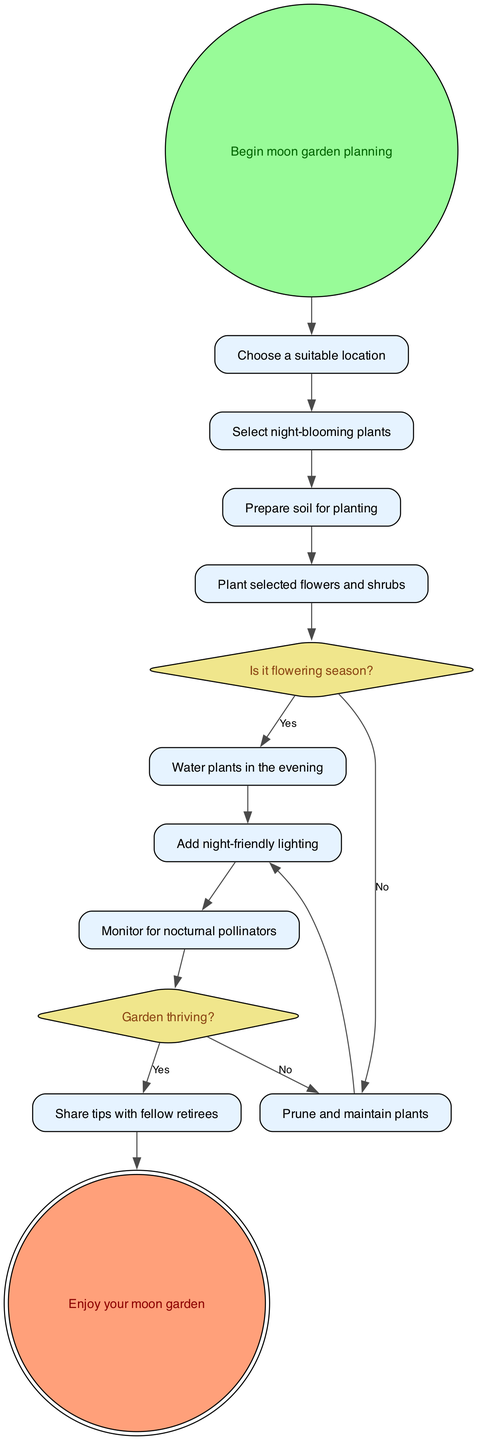What is the first step in creating a moon garden? The first step indicated in the diagram is "Begin moon garden planning," which initiates the process of creating the moon garden.
Answer: Begin moon garden planning How many decision nodes are in the diagram? By counting the types of elements labeled as decision in the diagram, we find there are two decision nodes: "Is it flowering season?" and "Garden thriving?"
Answer: 2 What action follows "Prepare soil for planting"? The next action after "Prepare soil for planting" is "Plant selected flowers and shrubs," which is the subsequent step in the planting process.
Answer: Plant selected flowers and shrubs What happens after monitoring for nocturnal pollinators? After "Monitor for nocturnal pollinators," the decision node "Garden thriving?" follows, which determines the next steps based on the garden's success.
Answer: Garden thriving? What should you do if the garden is thriving? If the garden is thriving, the diagram leads to the action "Share tips with fellow retirees," indicating a positive outcome for your moon garden efforts.
Answer: Share tips with fellow retirees What is the outcome of this entire process? The final outcome after completing all steps is "Enjoy your moon garden," which signifies the conclusion of the activity diagram.
Answer: Enjoy your moon garden What action is taken if the flowering season has not arrived? If it is determined that it is not the flowering season, the action that should be taken is "Prune and maintain plants," suggesting ongoing care for the plants even before they bloom.
Answer: Prune and maintain plants What type of plants should be selected for the moon garden? The diagram specifies that one should "Select night-blooming plants," indicating the focus on plants that will flower and attract nocturnal pollinators during nighttime.
Answer: Night-blooming plants What is the purpose of adding night-friendly lighting? The action "Add night-friendly lighting" is aimed at enhancing visibility and attracting nocturnal pollinators, creating a welcoming environment for them in the moon garden.
Answer: Attract nocturnal pollinators 